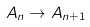<formula> <loc_0><loc_0><loc_500><loc_500>A _ { n } \to A _ { n + 1 }</formula> 